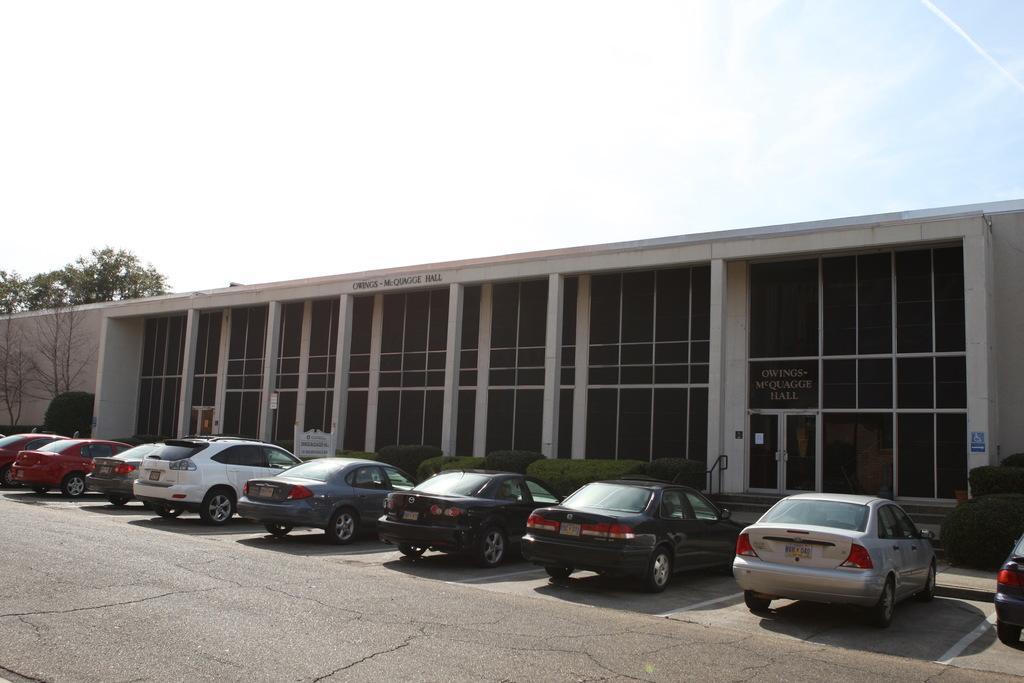Please provide a concise description of this image. In the picture we can see a building with glasses to it with pillars and near it, we can see some plants and some cars are parked and behind the building we can see trees and sky with clouds 